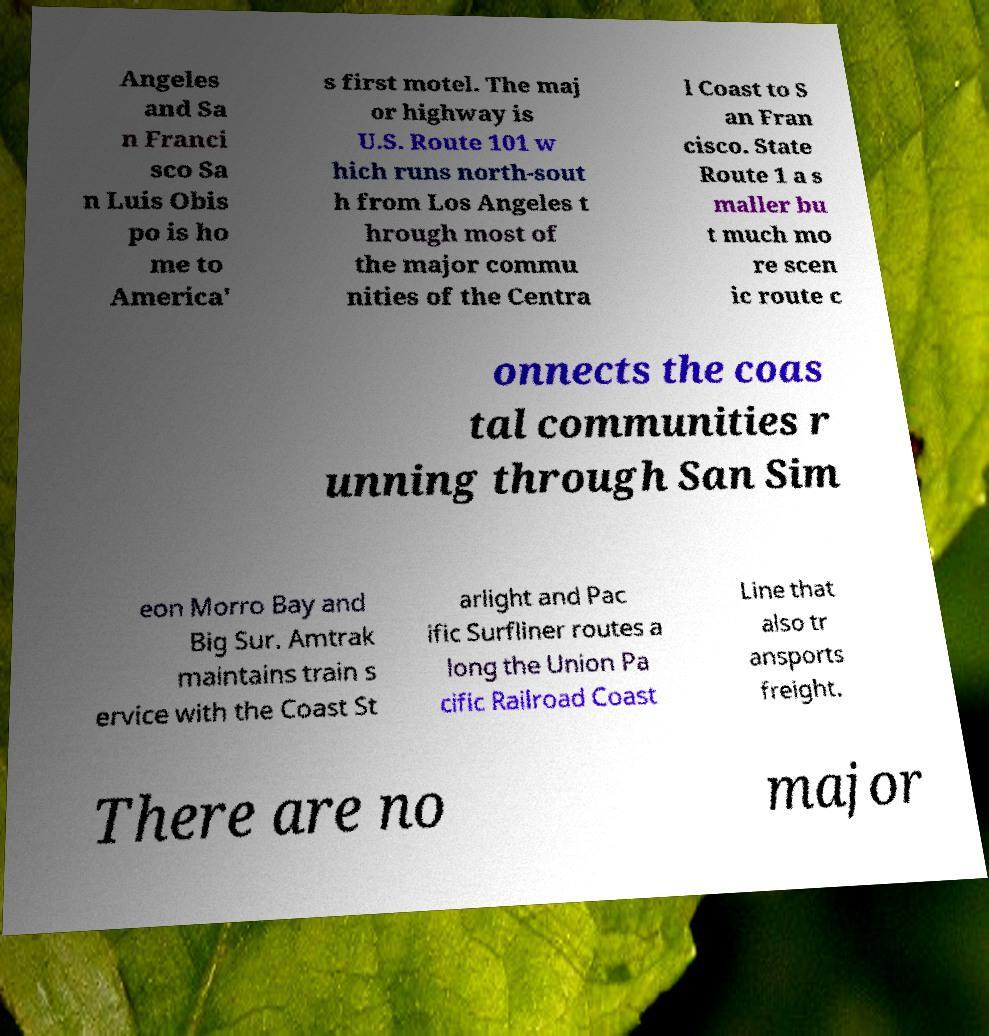For documentation purposes, I need the text within this image transcribed. Could you provide that? Angeles and Sa n Franci sco Sa n Luis Obis po is ho me to America' s first motel. The maj or highway is U.S. Route 101 w hich runs north-sout h from Los Angeles t hrough most of the major commu nities of the Centra l Coast to S an Fran cisco. State Route 1 a s maller bu t much mo re scen ic route c onnects the coas tal communities r unning through San Sim eon Morro Bay and Big Sur. Amtrak maintains train s ervice with the Coast St arlight and Pac ific Surfliner routes a long the Union Pa cific Railroad Coast Line that also tr ansports freight. There are no major 